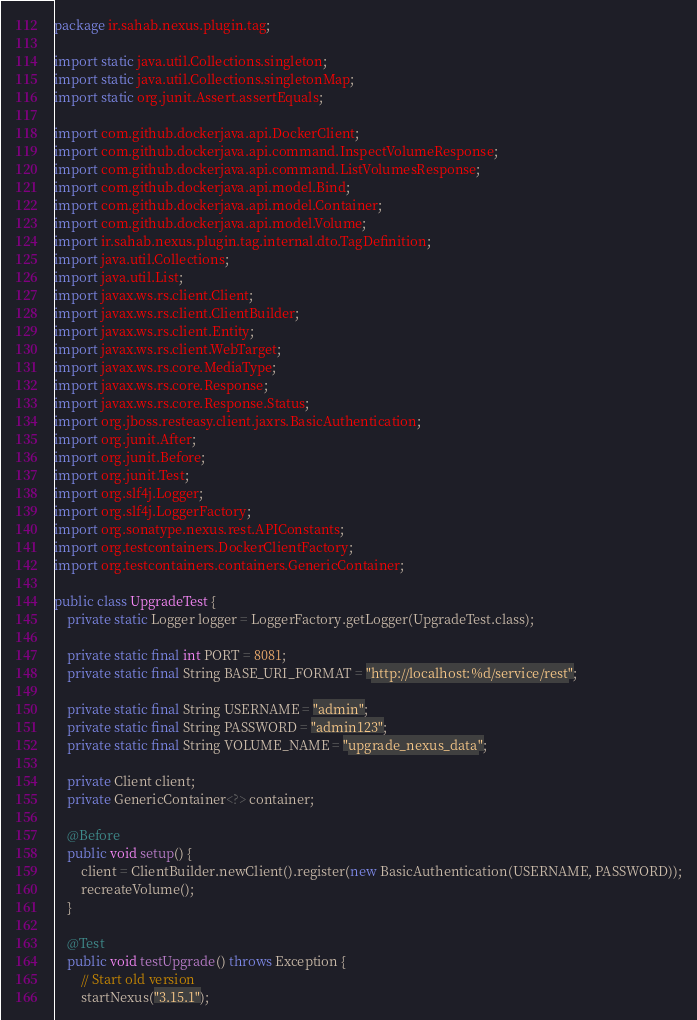<code> <loc_0><loc_0><loc_500><loc_500><_Java_>package ir.sahab.nexus.plugin.tag;

import static java.util.Collections.singleton;
import static java.util.Collections.singletonMap;
import static org.junit.Assert.assertEquals;

import com.github.dockerjava.api.DockerClient;
import com.github.dockerjava.api.command.InspectVolumeResponse;
import com.github.dockerjava.api.command.ListVolumesResponse;
import com.github.dockerjava.api.model.Bind;
import com.github.dockerjava.api.model.Container;
import com.github.dockerjava.api.model.Volume;
import ir.sahab.nexus.plugin.tag.internal.dto.TagDefinition;
import java.util.Collections;
import java.util.List;
import javax.ws.rs.client.Client;
import javax.ws.rs.client.ClientBuilder;
import javax.ws.rs.client.Entity;
import javax.ws.rs.client.WebTarget;
import javax.ws.rs.core.MediaType;
import javax.ws.rs.core.Response;
import javax.ws.rs.core.Response.Status;
import org.jboss.resteasy.client.jaxrs.BasicAuthentication;
import org.junit.After;
import org.junit.Before;
import org.junit.Test;
import org.slf4j.Logger;
import org.slf4j.LoggerFactory;
import org.sonatype.nexus.rest.APIConstants;
import org.testcontainers.DockerClientFactory;
import org.testcontainers.containers.GenericContainer;

public class UpgradeTest {
    private static Logger logger = LoggerFactory.getLogger(UpgradeTest.class);

    private static final int PORT = 8081;
    private static final String BASE_URI_FORMAT = "http://localhost:%d/service/rest";

    private static final String USERNAME = "admin";
    private static final String PASSWORD = "admin123";
    private static final String VOLUME_NAME = "upgrade_nexus_data";

    private Client client;
    private GenericContainer<?> container;

    @Before
    public void setup() {
        client = ClientBuilder.newClient().register(new BasicAuthentication(USERNAME, PASSWORD));
        recreateVolume();
    }

    @Test
    public void testUpgrade() throws Exception {
        // Start old version
        startNexus("3.15.1");
</code> 